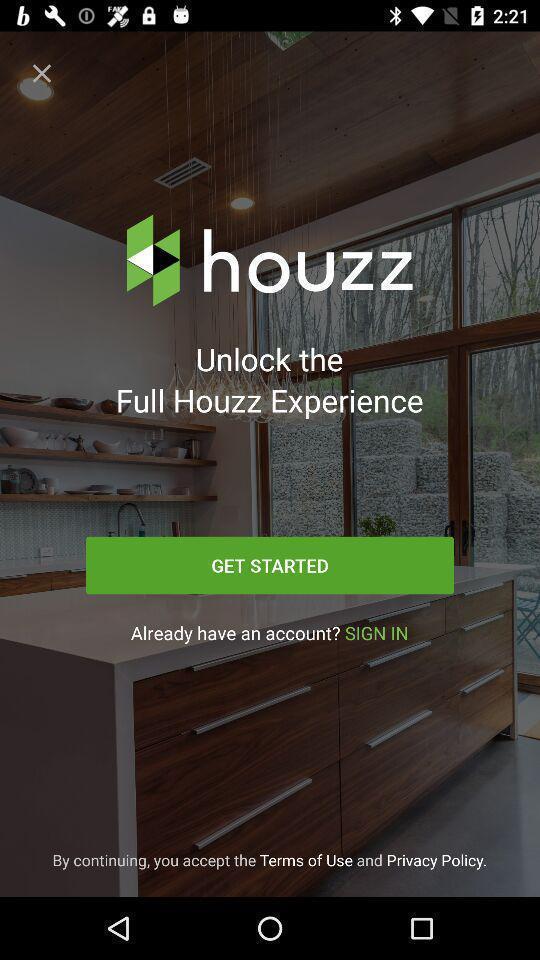What can you discern from this picture? Welcome page with get started option in decoration app. 